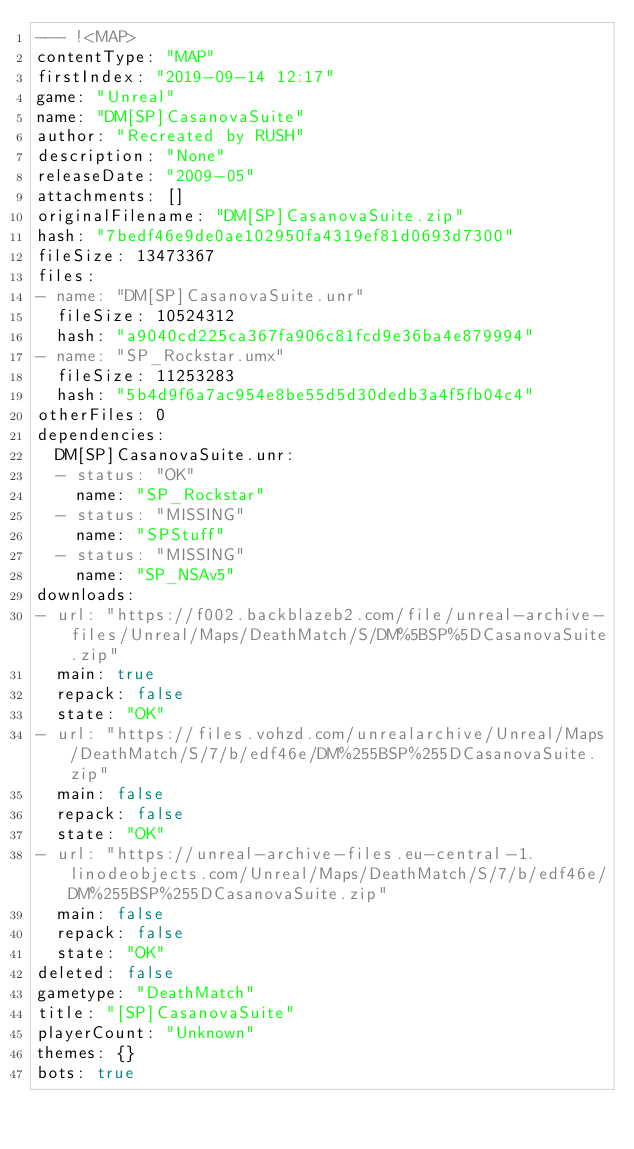<code> <loc_0><loc_0><loc_500><loc_500><_YAML_>--- !<MAP>
contentType: "MAP"
firstIndex: "2019-09-14 12:17"
game: "Unreal"
name: "DM[SP]CasanovaSuite"
author: "Recreated by RUSH"
description: "None"
releaseDate: "2009-05"
attachments: []
originalFilename: "DM[SP]CasanovaSuite.zip"
hash: "7bedf46e9de0ae102950fa4319ef81d0693d7300"
fileSize: 13473367
files:
- name: "DM[SP]CasanovaSuite.unr"
  fileSize: 10524312
  hash: "a9040cd225ca367fa906c81fcd9e36ba4e879994"
- name: "SP_Rockstar.umx"
  fileSize: 11253283
  hash: "5b4d9f6a7ac954e8be55d5d30dedb3a4f5fb04c4"
otherFiles: 0
dependencies:
  DM[SP]CasanovaSuite.unr:
  - status: "OK"
    name: "SP_Rockstar"
  - status: "MISSING"
    name: "SPStuff"
  - status: "MISSING"
    name: "SP_NSAv5"
downloads:
- url: "https://f002.backblazeb2.com/file/unreal-archive-files/Unreal/Maps/DeathMatch/S/DM%5BSP%5DCasanovaSuite.zip"
  main: true
  repack: false
  state: "OK"
- url: "https://files.vohzd.com/unrealarchive/Unreal/Maps/DeathMatch/S/7/b/edf46e/DM%255BSP%255DCasanovaSuite.zip"
  main: false
  repack: false
  state: "OK"
- url: "https://unreal-archive-files.eu-central-1.linodeobjects.com/Unreal/Maps/DeathMatch/S/7/b/edf46e/DM%255BSP%255DCasanovaSuite.zip"
  main: false
  repack: false
  state: "OK"
deleted: false
gametype: "DeathMatch"
title: "[SP]CasanovaSuite"
playerCount: "Unknown"
themes: {}
bots: true
</code> 